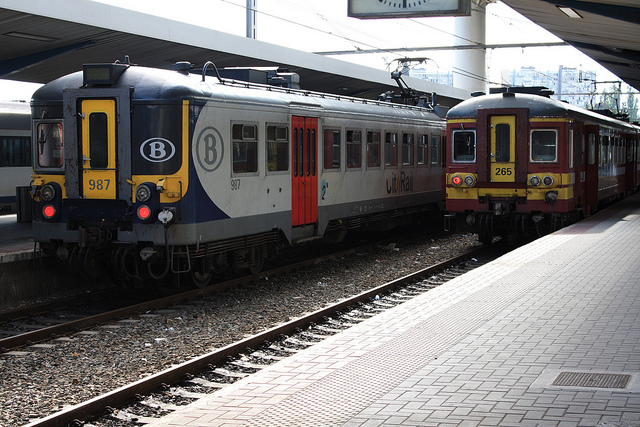How many trains are there? 3 